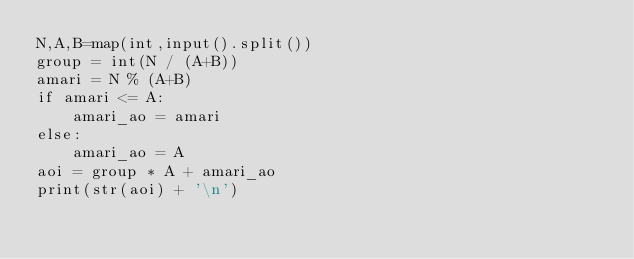<code> <loc_0><loc_0><loc_500><loc_500><_Python_>N,A,B=map(int,input().split())
group = int(N / (A+B))
amari = N % (A+B)
if amari <= A:
    amari_ao = amari
else:
    amari_ao = A
aoi = group * A + amari_ao
print(str(aoi) + '\n')</code> 